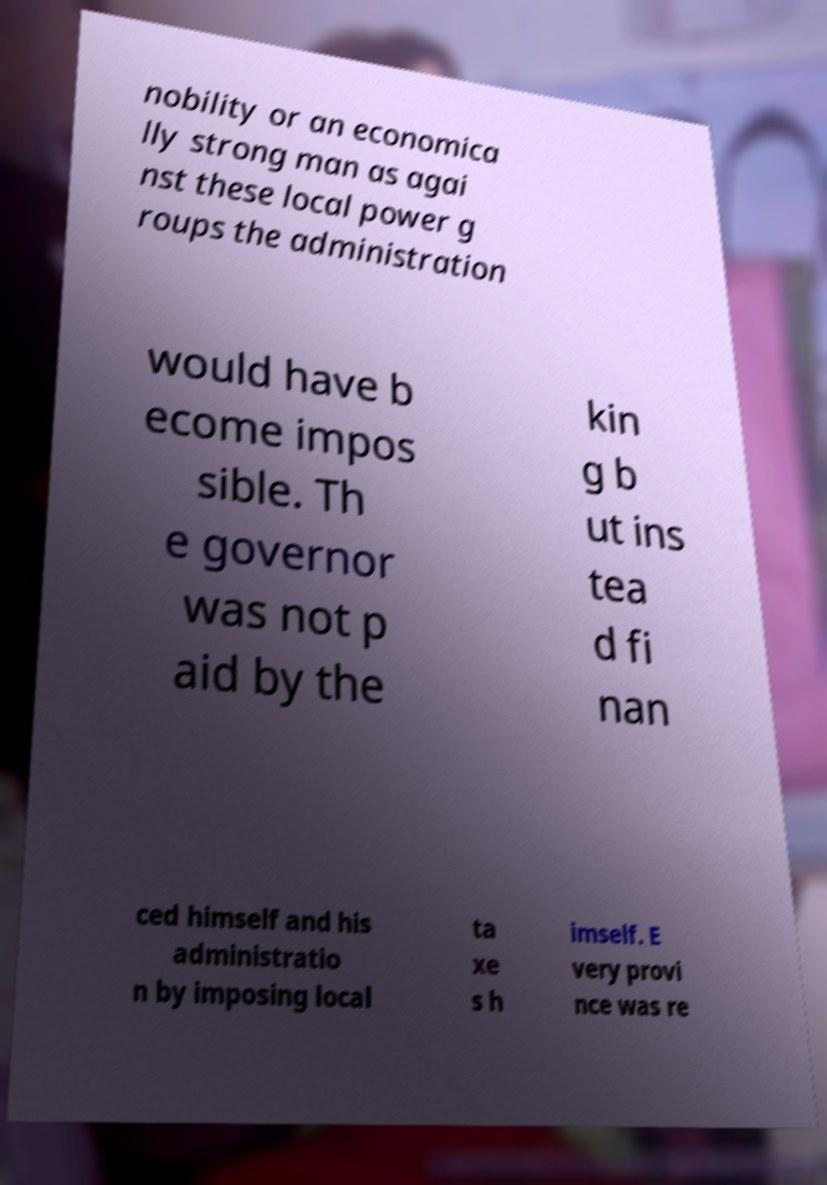Please identify and transcribe the text found in this image. nobility or an economica lly strong man as agai nst these local power g roups the administration would have b ecome impos sible. Th e governor was not p aid by the kin g b ut ins tea d fi nan ced himself and his administratio n by imposing local ta xe s h imself. E very provi nce was re 